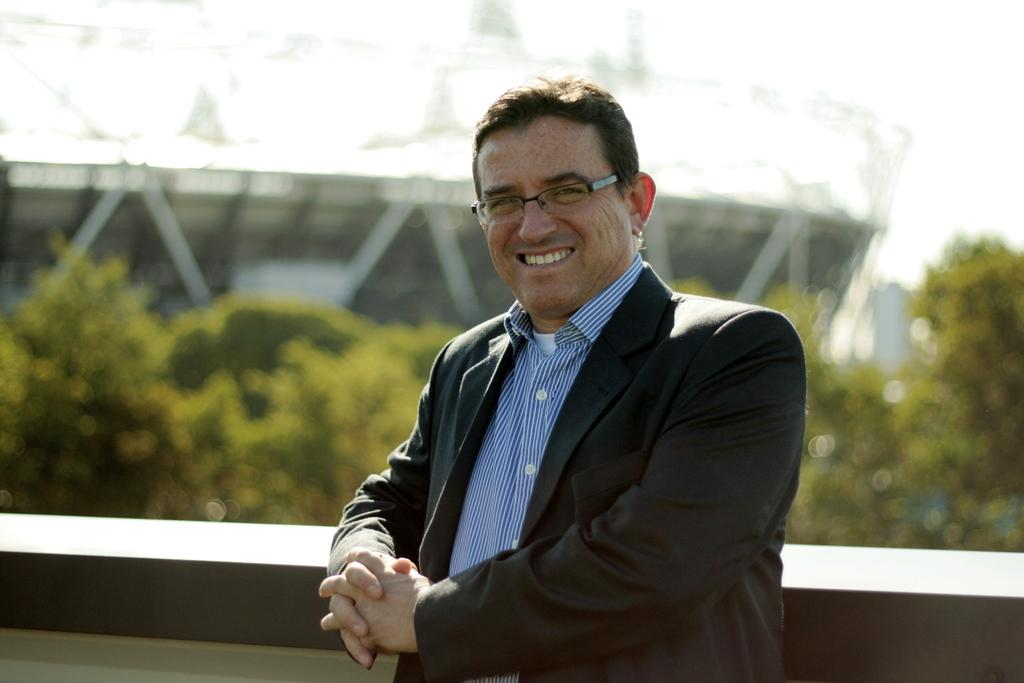What is the main subject of the image? There is a man standing in the middle of the image. What is the man doing in the image? The man is smiling in the image. What can be seen behind the man? There is a wall behind the man. What is visible in the background of the image? Trees, a building, and the sky are visible in the background of the image. What type of machine is being used to produce the oil in the image? There is no machine or oil production visible in the image; it features a man standing and smiling. What month is it in the image? The image does not provide any information about the month or time of year. 